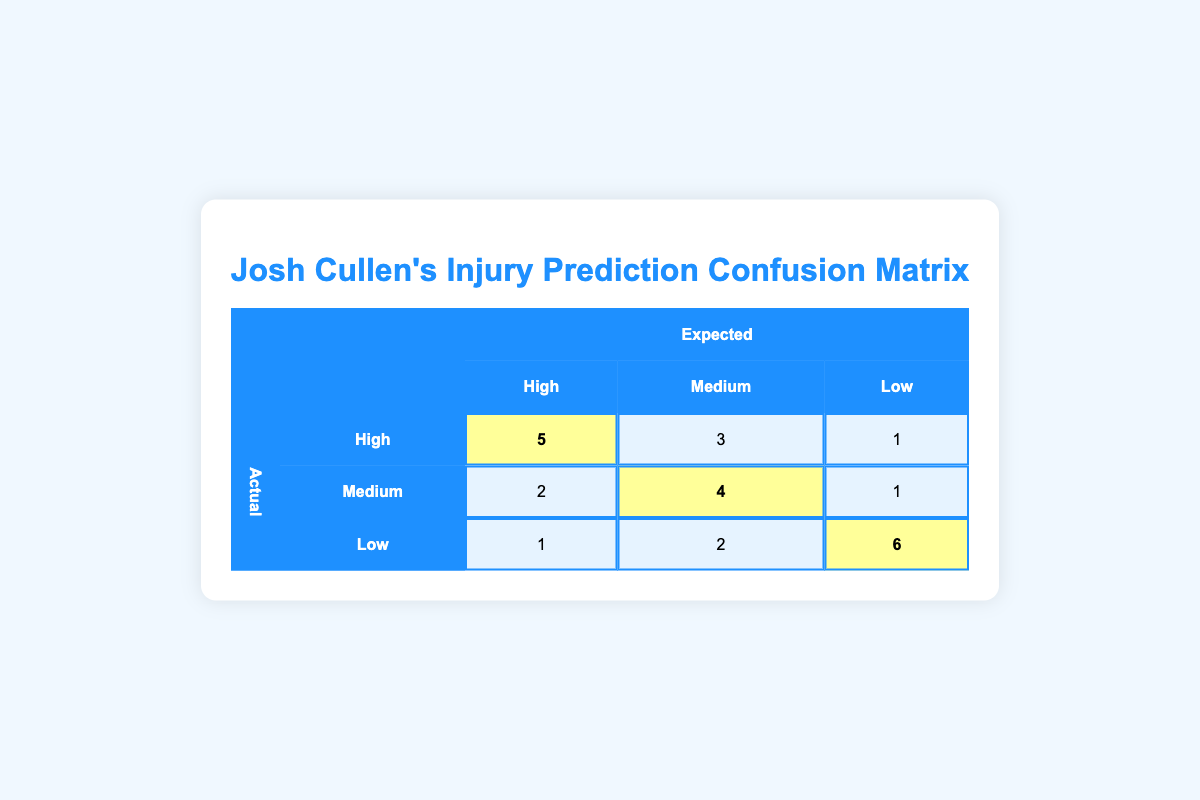What is the count of actual injuries classified as "High" when the expected injuries are also "High"? The table shows that when the expected injuries are "High," the actual count of injuries in that category is 5.
Answer: 5 How many "Medium" injuries were expected but classified as "High"? By looking at the row for expected "Medium" and actual "High," the count is 3.
Answer: 3 What is the total count of injuries predicted as "Low"? The total count of injuries predicted as "Low" can be found by adding the counts from the "Low" expected category: 1 (actual High) + 2 (actual Medium) + 6 (actual Low) = 9.
Answer: 9 Did Josh Cullen's injury prediction model expect more "High" injuries than actual "Low" injuries? The model expected 5 "High" injuries, while the actual count for "Low" injuries is 6, so the statement is false.
Answer: No What is the average number of actual injuries across all expected categories? To calculate the average, sum all counts (5 + 3 + 1 + 2 + 4 + 1 + 1 + 2 + 6 = 25), and since there are 9 entries, the average is 25/9 ≈ 2.78.
Answer: Approximately 2.78 How many actual "Medium" injuries were reported compared to the expected count of "Medium"? The expected count of "Medium" injuries is 4 (actual Medium), while the actual count of "Medium" injuries from the entire data is 3 + 4 + 1 = 8. Therefore, it had more actual injuries than expected in that category.
Answer: Yes What is the highest number of actual injuries recorded in a single expected category? Looking through the table, the highest count of actual injuries categorized by any expected type is 6 for "Low."
Answer: 6 What were the actual counts of injuries when expected injuries were classified as "High"? The actual counts for expected "High" are: High (5), Medium (3), Low (1).
Answer: 5, 3, 1 How many more actual "Low" injury counts occur compared to actual "High" injury counts? By subtracting the counts, we see there are 6 actual "Low" injuries and 5 actual "High" injuries. Thus, 6 - 5 = 1.
Answer: 1 